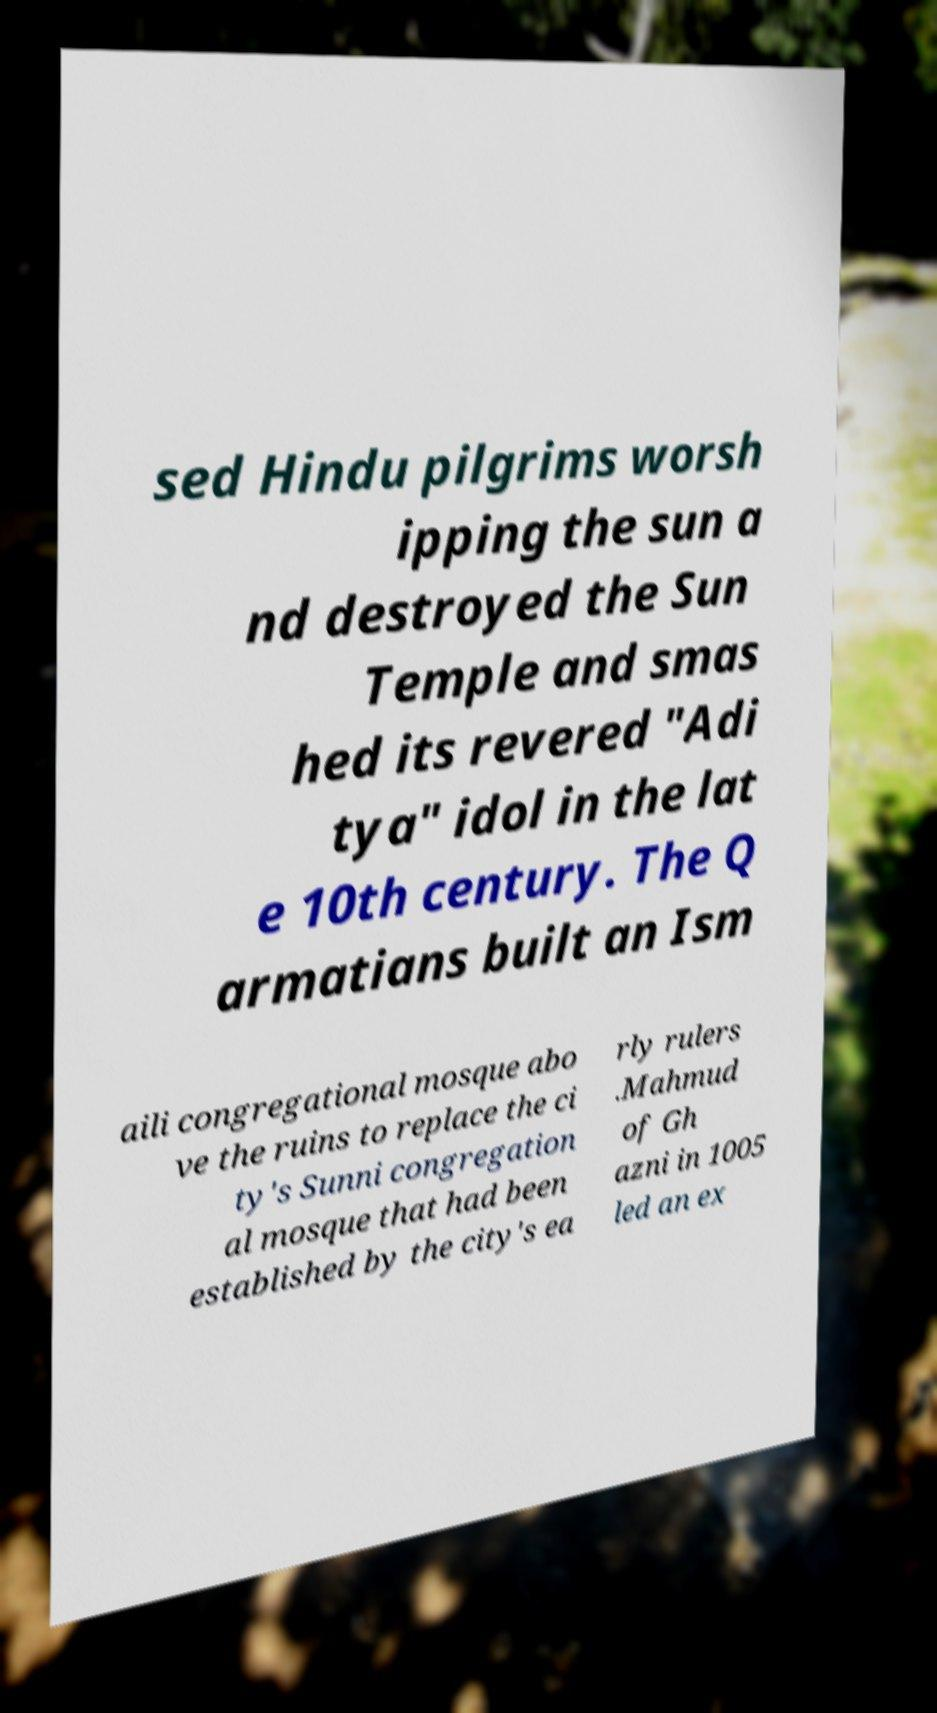Please read and relay the text visible in this image. What does it say? sed Hindu pilgrims worsh ipping the sun a nd destroyed the Sun Temple and smas hed its revered "Adi tya" idol in the lat e 10th century. The Q armatians built an Ism aili congregational mosque abo ve the ruins to replace the ci ty's Sunni congregation al mosque that had been established by the city's ea rly rulers .Mahmud of Gh azni in 1005 led an ex 